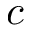Convert formula to latex. <formula><loc_0><loc_0><loc_500><loc_500>c</formula> 